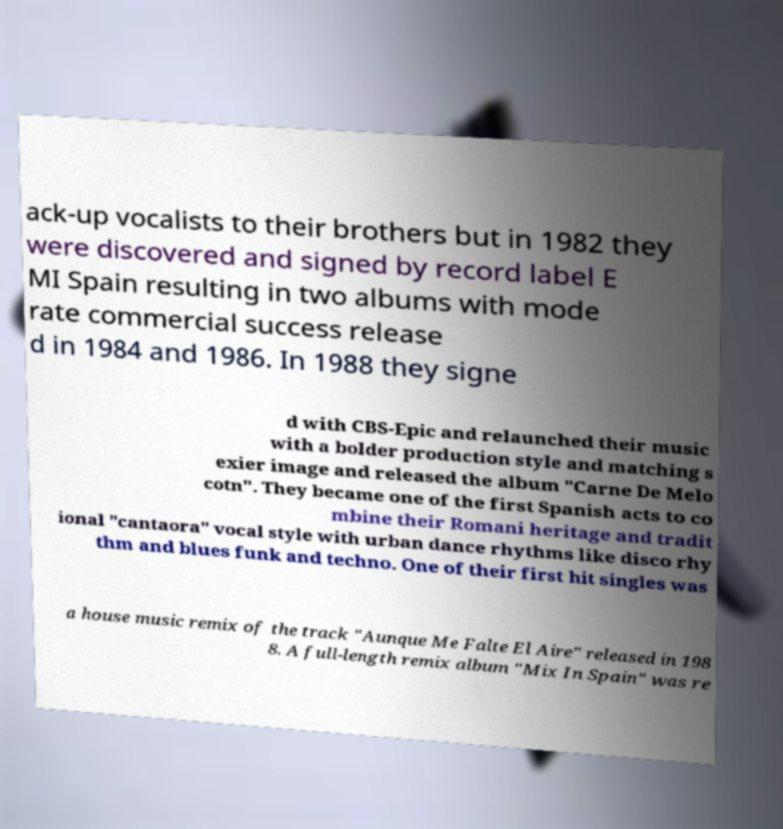There's text embedded in this image that I need extracted. Can you transcribe it verbatim? ack-up vocalists to their brothers but in 1982 they were discovered and signed by record label E MI Spain resulting in two albums with mode rate commercial success release d in 1984 and 1986. In 1988 they signe d with CBS-Epic and relaunched their music with a bolder production style and matching s exier image and released the album "Carne De Melo cotn". They became one of the first Spanish acts to co mbine their Romani heritage and tradit ional "cantaora" vocal style with urban dance rhythms like disco rhy thm and blues funk and techno. One of their first hit singles was a house music remix of the track "Aunque Me Falte El Aire" released in 198 8. A full-length remix album "Mix In Spain" was re 